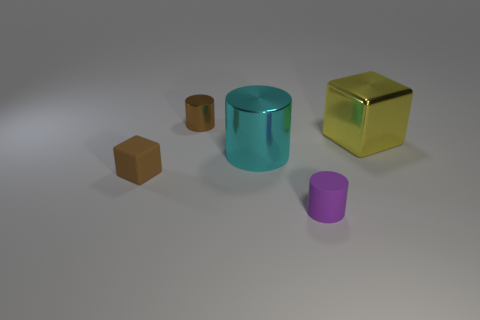How many things have the same color as the tiny cube?
Provide a succinct answer. 1. What is the size of the brown object that is made of the same material as the large cylinder?
Provide a succinct answer. Small. There is a shiny thing behind the yellow metallic thing; what is its shape?
Ensure brevity in your answer.  Cylinder. There is a brown object that is the same shape as the cyan metal object; what is its size?
Offer a terse response. Small. There is a matte object that is to the left of the tiny cylinder behind the large cyan cylinder; how many tiny brown rubber cubes are to the right of it?
Make the answer very short. 0. Are there the same number of cylinders in front of the brown metallic cylinder and big shiny things?
Give a very brief answer. Yes. How many blocks are either small metallic objects or tiny brown rubber things?
Your answer should be very brief. 1. Is the tiny matte block the same color as the rubber cylinder?
Provide a short and direct response. No. Are there an equal number of brown blocks that are behind the big cylinder and small metal objects that are on the left side of the small brown block?
Offer a very short reply. Yes. The small block is what color?
Make the answer very short. Brown. 